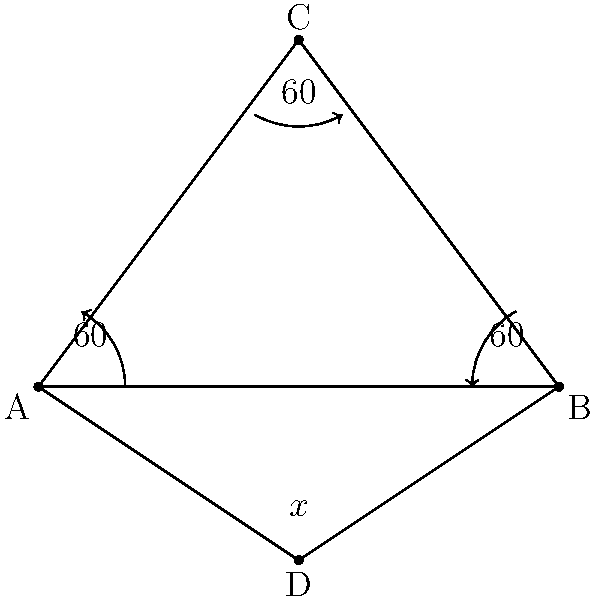During a compass navigation exercise, you encounter a triangular landmark ABC with an equilateral base. Point D is located on the perpendicular bisector of AB. If the angles at A, B, and C are all 60°, what is the measure of angle ADB? Let's approach this step-by-step:

1) First, we recognize that triangle ABC is equilateral, as all angles are 60°.

2) Point D is on the perpendicular bisector of AB. This means that AD = BD, and the line CD is perpendicular to AB.

3) In an equilateral triangle, the perpendicular bisector of a side passes through the opposite vertex. Therefore, CD is also the height of the triangle.

4) Now, let's focus on triangle ADB:
   - We know that AD = BD (D is on the perpendicular bisector)
   - We know that angle DAB = angle DBA = 60° (they are base angles of the equilateral triangle)

5) Since the sum of angles in a triangle is always 180°, we can calculate angle ADB:

   $$180° = 60° + 60° + x°$$
   $$x° = 180° - 120° = 60°$$

6) Therefore, angle ADB must also be 60°.

This result is consistent with the fact that if two angles of a triangle are equal, the triangle must be isosceles, and if all three angles are equal (as we've shown here), the triangle must be equilateral.
Answer: 60° 